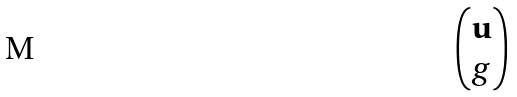Convert formula to latex. <formula><loc_0><loc_0><loc_500><loc_500>\begin{pmatrix} \mathbf u \\ g \end{pmatrix}</formula> 